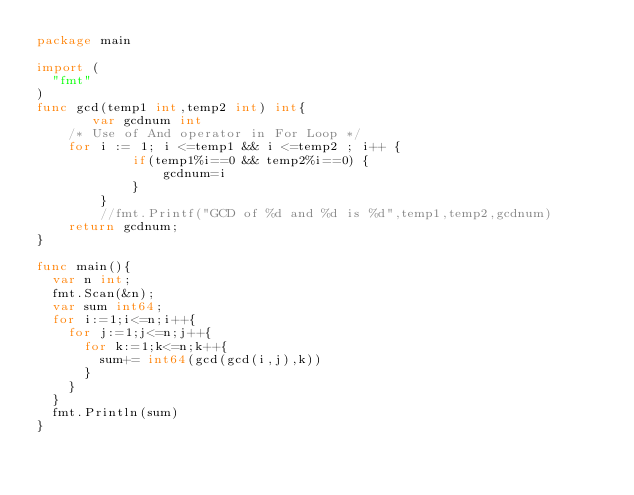<code> <loc_0><loc_0><loc_500><loc_500><_Go_>package main

import (
  "fmt"
)
func gcd(temp1 int,temp2 int) int{
       var gcdnum int
    /* Use of And operator in For Loop */  
    for i := 1; i <=temp1 && i <=temp2 ; i++ {
            if(temp1%i==0 && temp2%i==0) {
                gcdnum=i
            } 
        }
        //fmt.Printf("GCD of %d and %d is %d",temp1,temp2,gcdnum)
    return gcdnum;
}  

func main(){
  var n int;
  fmt.Scan(&n);
  var sum int64;
  for i:=1;i<=n;i++{
    for j:=1;j<=n;j++{
      for k:=1;k<=n;k++{
        sum+= int64(gcd(gcd(i,j),k))
      }
    }
  }
  fmt.Println(sum)
}</code> 